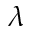<formula> <loc_0><loc_0><loc_500><loc_500>\lambda</formula> 